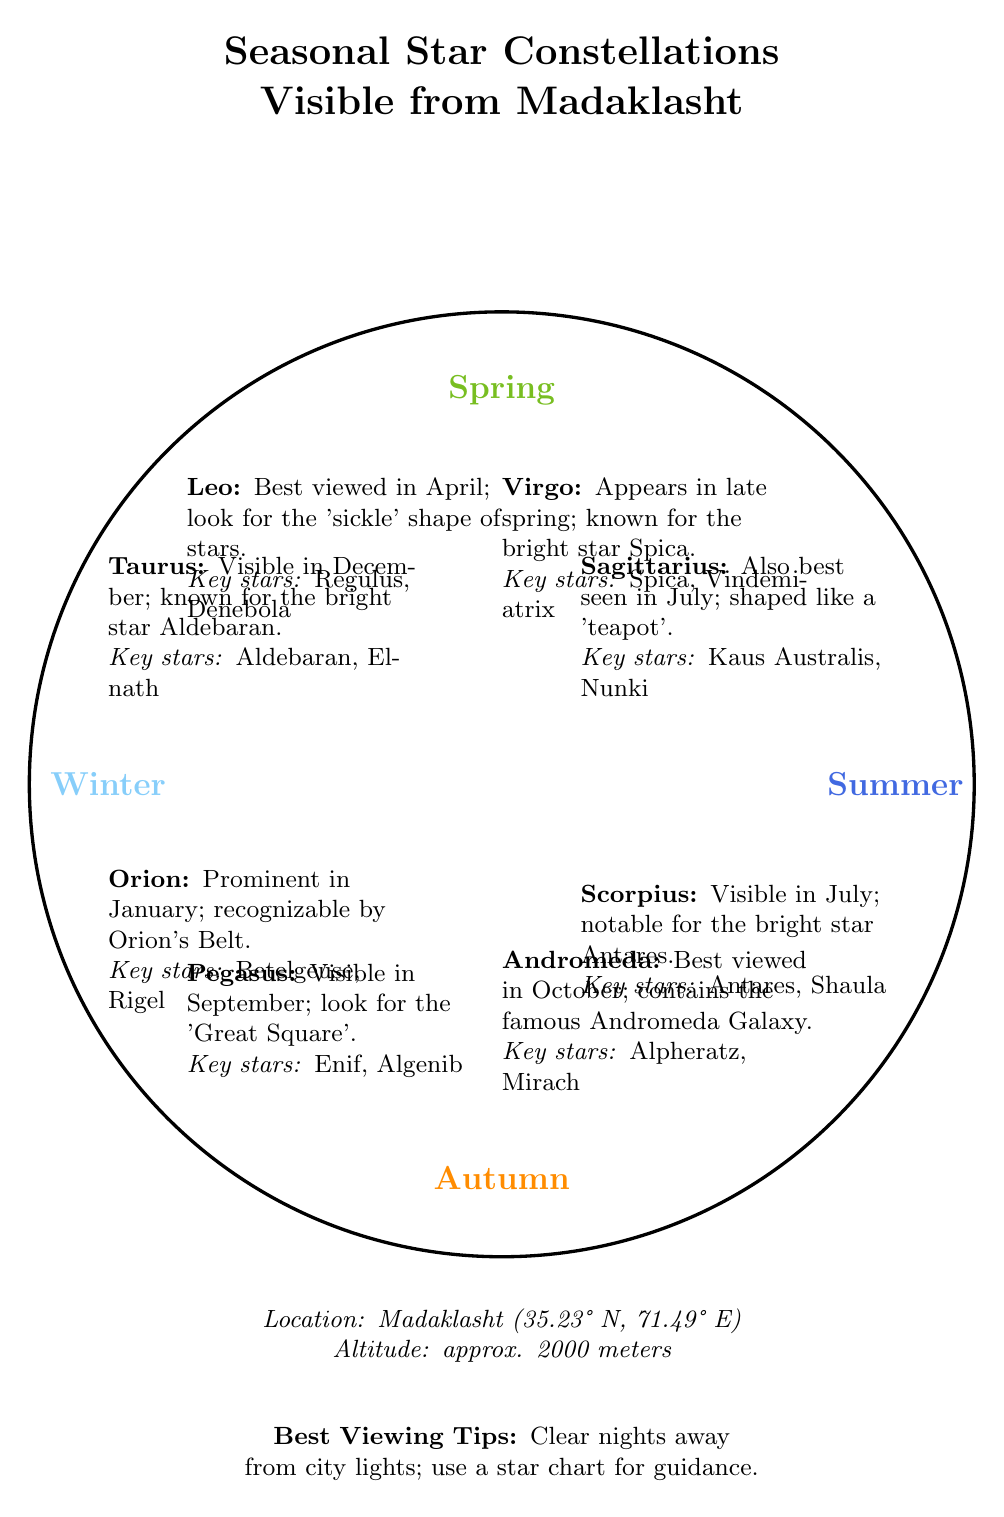What are the four seasons represented in the diagram? The diagram clearly labels four distinct sections corresponding to the seasons: Spring, Summer, Autumn, and Winter.
Answer: Spring, Summer, Autumn, Winter Which constellation is visible in July? The diagram shows that both Scorpius and Sagittarius are visible in July. By looking at their respective labels, Scorpius is mentioned as visible in July and includes notable stars.
Answer: Scorpius What is the key star of Virgo? The diagram states that Spica is the key star for Virgo, found in the description for this constellation located in the Spring section.
Answer: Spica How many constellations are listed for Autumn? By examining the Autumn section of the diagram, it shows only one constellation, Pegasus. Thus, counting the constellations listed, we find the answer.
Answer: 1 Which constellation is associated with a 'teapot' shape? In the Summer section of the diagram, Sagittarius is identified by its 'teapot' shape, directly mentioned in the description.
Answer: Sagittarius During which month is Orion best viewed? The diagram specifies that Orion is prominent in January. By finding the location of Orion in the Winter section, the answer can be determined.
Answer: January What altitude is mentioned for Madaklasht? The diagram includes the altitude of Madaklasht, specifying it is approximately 2000 meters. This information is provided in the lower part of the diagram.
Answer: 2000 meters What is a key viewing tip given in the diagram? The diagram suggests one of the best viewing tips is to find clear nights away from city lights, which helps to enhance visibility of the stars as listed.
Answer: Clear nights away from city lights Which constellation contains the Andromeda Galaxy? The diagram describes Andromeda as best viewed in October and explicitly mentions it contains the famous Andromeda Galaxy, making the connection clear.
Answer: Andromeda 